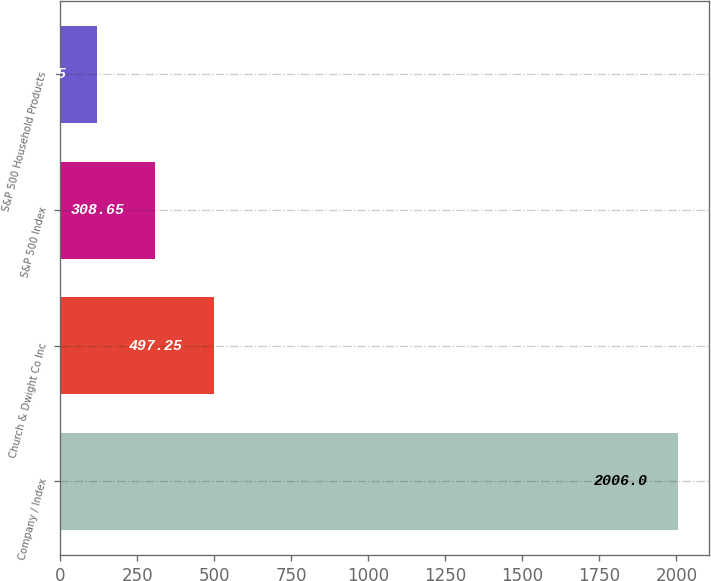Convert chart to OTSL. <chart><loc_0><loc_0><loc_500><loc_500><bar_chart><fcel>Company / Index<fcel>Church & Dwight Co Inc<fcel>S&P 500 Index<fcel>S&P 500 Household Products<nl><fcel>2006<fcel>497.25<fcel>308.65<fcel>120.05<nl></chart> 